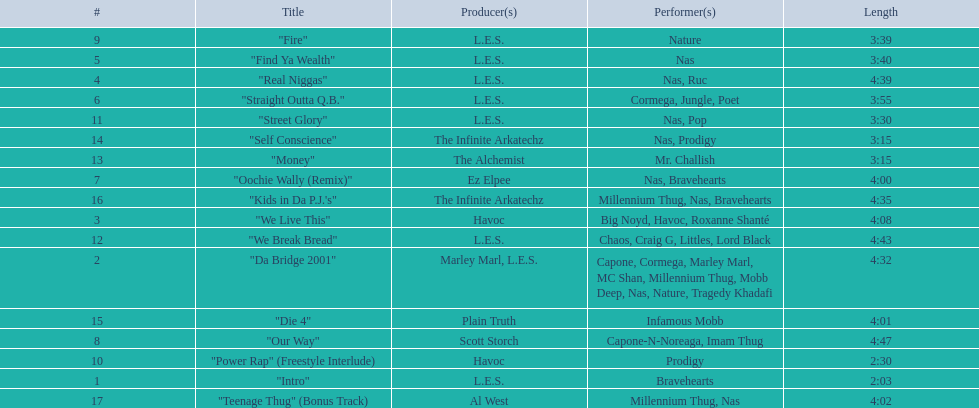How long is the longest track listed? 4:47. 